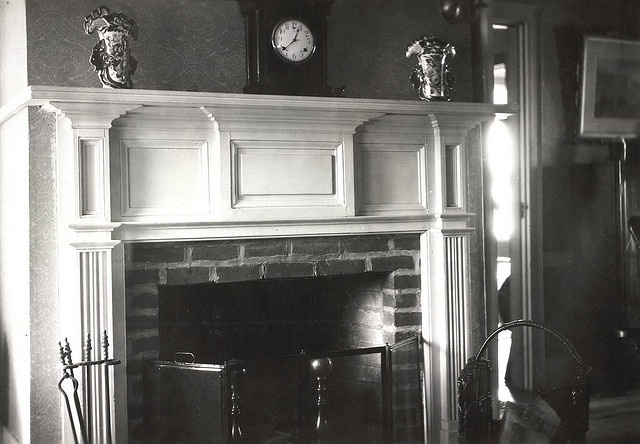Describe the objects in this image and their specific colors. I can see vase in darkgray, gray, black, and white tones, vase in darkgray, black, gray, and lightgray tones, and clock in darkgray, black, gray, and lightgray tones in this image. 